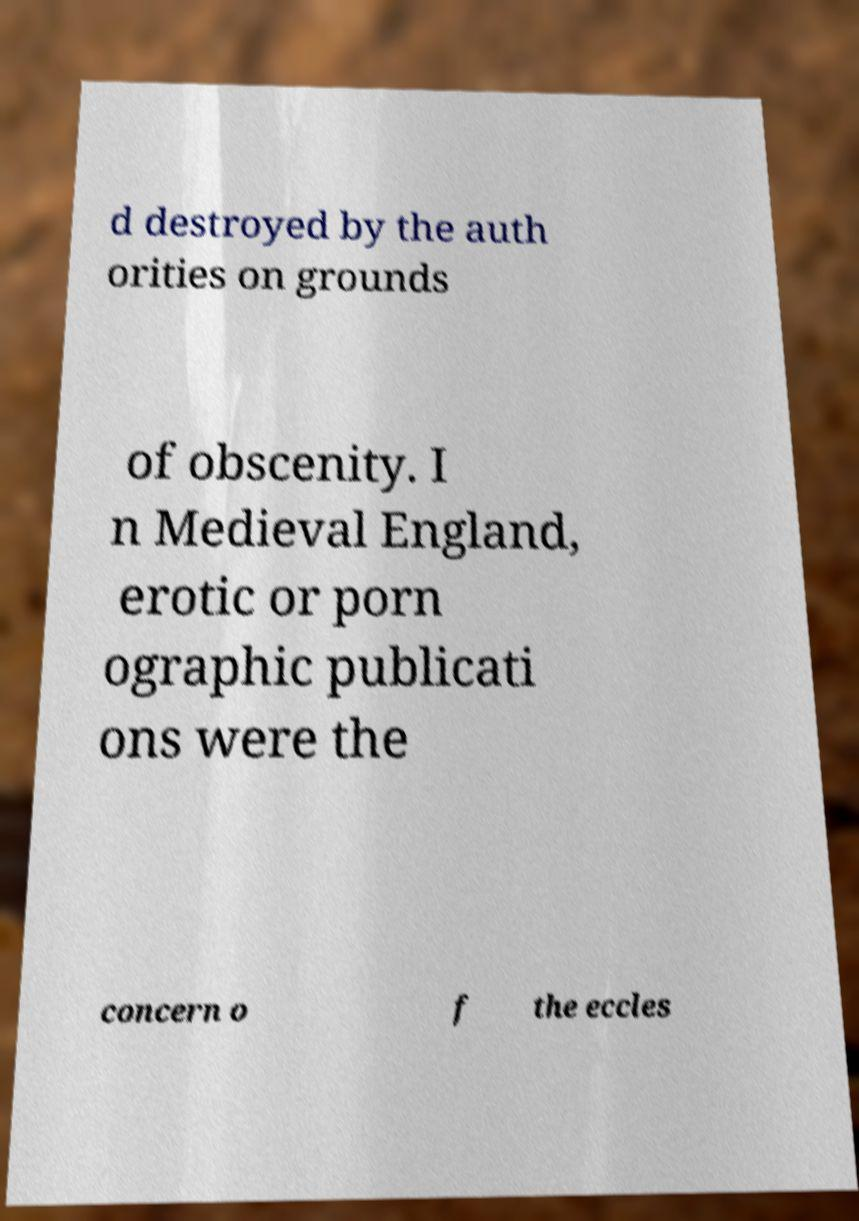I need the written content from this picture converted into text. Can you do that? d destroyed by the auth orities on grounds of obscenity. I n Medieval England, erotic or porn ographic publicati ons were the concern o f the eccles 